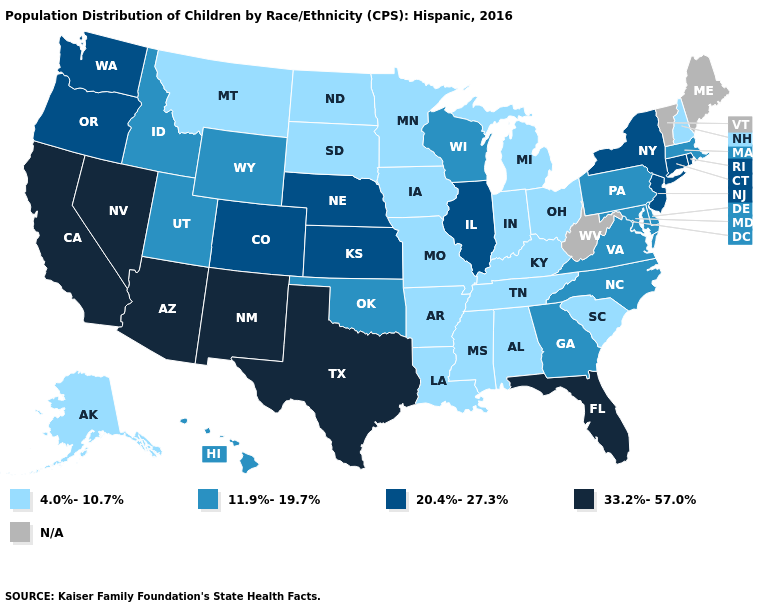Which states have the highest value in the USA?
Concise answer only. Arizona, California, Florida, Nevada, New Mexico, Texas. Name the states that have a value in the range 20.4%-27.3%?
Quick response, please. Colorado, Connecticut, Illinois, Kansas, Nebraska, New Jersey, New York, Oregon, Rhode Island, Washington. Does the first symbol in the legend represent the smallest category?
Write a very short answer. Yes. Does Alabama have the lowest value in the USA?
Be succinct. Yes. Does Utah have the highest value in the West?
Answer briefly. No. What is the value of Florida?
Write a very short answer. 33.2%-57.0%. Does the map have missing data?
Answer briefly. Yes. What is the value of Rhode Island?
Be succinct. 20.4%-27.3%. What is the lowest value in the MidWest?
Be succinct. 4.0%-10.7%. What is the lowest value in the MidWest?
Answer briefly. 4.0%-10.7%. Among the states that border Wisconsin , which have the lowest value?
Be succinct. Iowa, Michigan, Minnesota. Which states have the lowest value in the USA?
Answer briefly. Alabama, Alaska, Arkansas, Indiana, Iowa, Kentucky, Louisiana, Michigan, Minnesota, Mississippi, Missouri, Montana, New Hampshire, North Dakota, Ohio, South Carolina, South Dakota, Tennessee. Name the states that have a value in the range 11.9%-19.7%?
Quick response, please. Delaware, Georgia, Hawaii, Idaho, Maryland, Massachusetts, North Carolina, Oklahoma, Pennsylvania, Utah, Virginia, Wisconsin, Wyoming. Which states have the lowest value in the West?
Quick response, please. Alaska, Montana. Does South Dakota have the lowest value in the USA?
Give a very brief answer. Yes. 